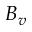<formula> <loc_0><loc_0><loc_500><loc_500>B _ { v }</formula> 